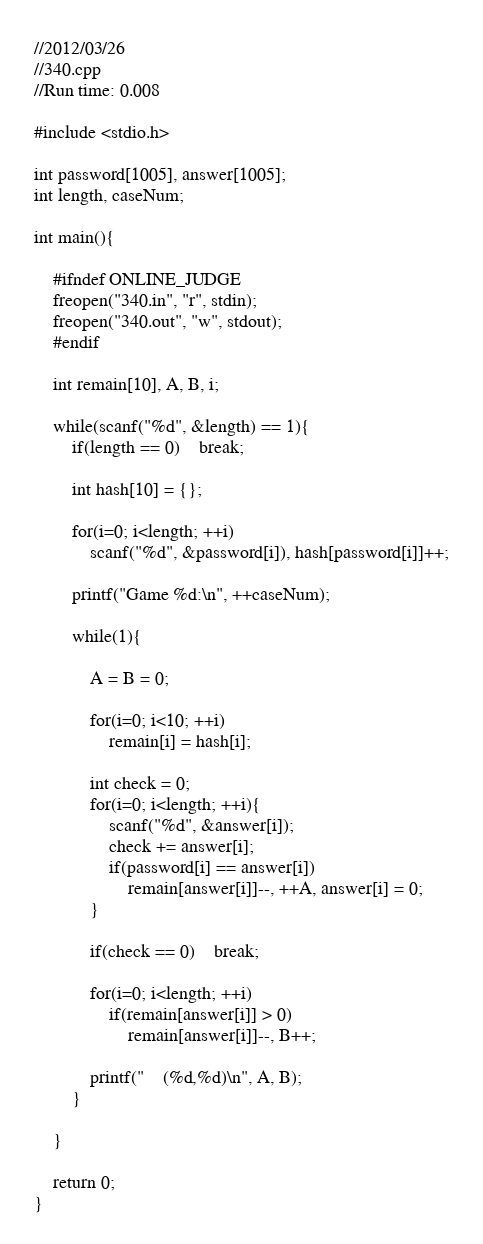<code> <loc_0><loc_0><loc_500><loc_500><_C++_>//2012/03/26
//340.cpp
//Run time: 0.008

#include <stdio.h>

int password[1005], answer[1005];
int length, caseNum;

int main(){

	#ifndef ONLINE_JUDGE
	freopen("340.in", "r", stdin);
	freopen("340.out", "w", stdout);
	#endif

	int remain[10], A, B, i;

	while(scanf("%d", &length) == 1){
		if(length == 0)	break;

		int hash[10] = {};

		for(i=0; i<length; ++i)
			scanf("%d", &password[i]), hash[password[i]]++;

		printf("Game %d:\n", ++caseNum);

		while(1){

			A = B = 0;

			for(i=0; i<10; ++i)
				remain[i] = hash[i];

			int check = 0;
			for(i=0; i<length; ++i){
				scanf("%d", &answer[i]);
				check += answer[i];
				if(password[i] == answer[i])
					remain[answer[i]]--, ++A, answer[i] = 0;
			}

			if(check == 0)	break;

			for(i=0; i<length; ++i)
				if(remain[answer[i]] > 0)
					remain[answer[i]]--, B++;

			printf("    (%d,%d)\n", A, B);
		}

	}

	return 0;
}
</code> 